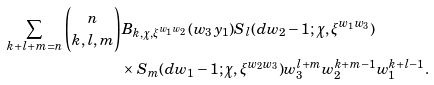Convert formula to latex. <formula><loc_0><loc_0><loc_500><loc_500>\sum _ { k + l + m = n } \binom { n } { k , l , m } & B _ { k , \chi , \xi ^ { w _ { 1 } w _ { 2 } } } ( w _ { 3 } y _ { 1 } ) S _ { l } ( d w _ { 2 } - 1 ; \chi , \xi ^ { w _ { 1 } w _ { 3 } } ) \\ & \times S _ { m } ( d w _ { 1 } - 1 ; \chi , \xi ^ { w _ { 2 } w _ { 3 } } ) w _ { 3 } ^ { l + m } w _ { 2 } ^ { k + m - 1 } w _ { 1 } ^ { k + l - 1 } .</formula> 